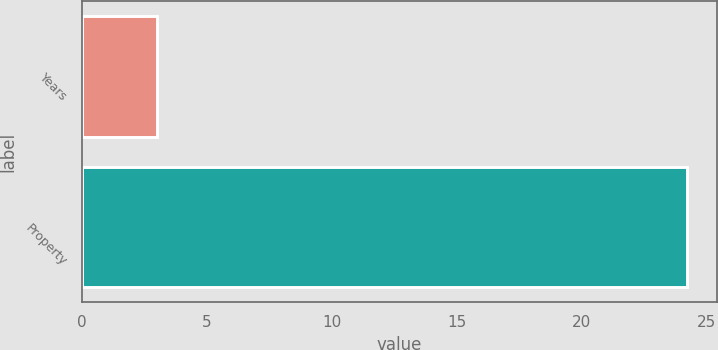Convert chart. <chart><loc_0><loc_0><loc_500><loc_500><bar_chart><fcel>Years<fcel>Property<nl><fcel>3<fcel>24.2<nl></chart> 